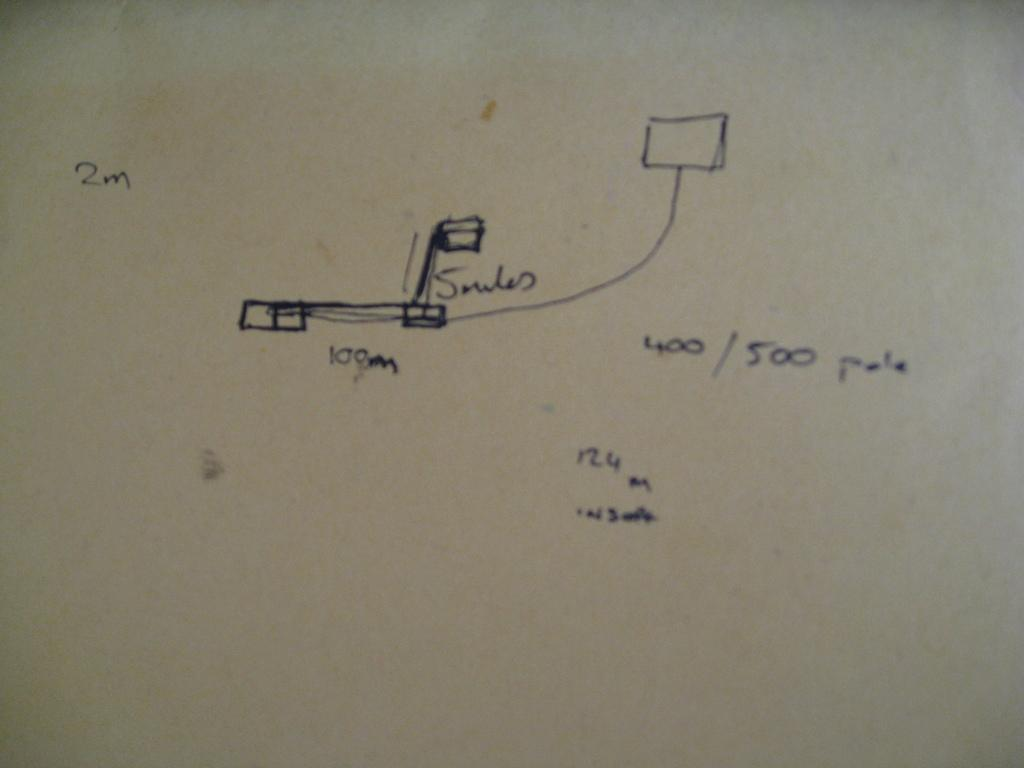<image>
Offer a succinct explanation of the picture presented. A diagram shows some boxes and measurements, including 100 meters for one part. 